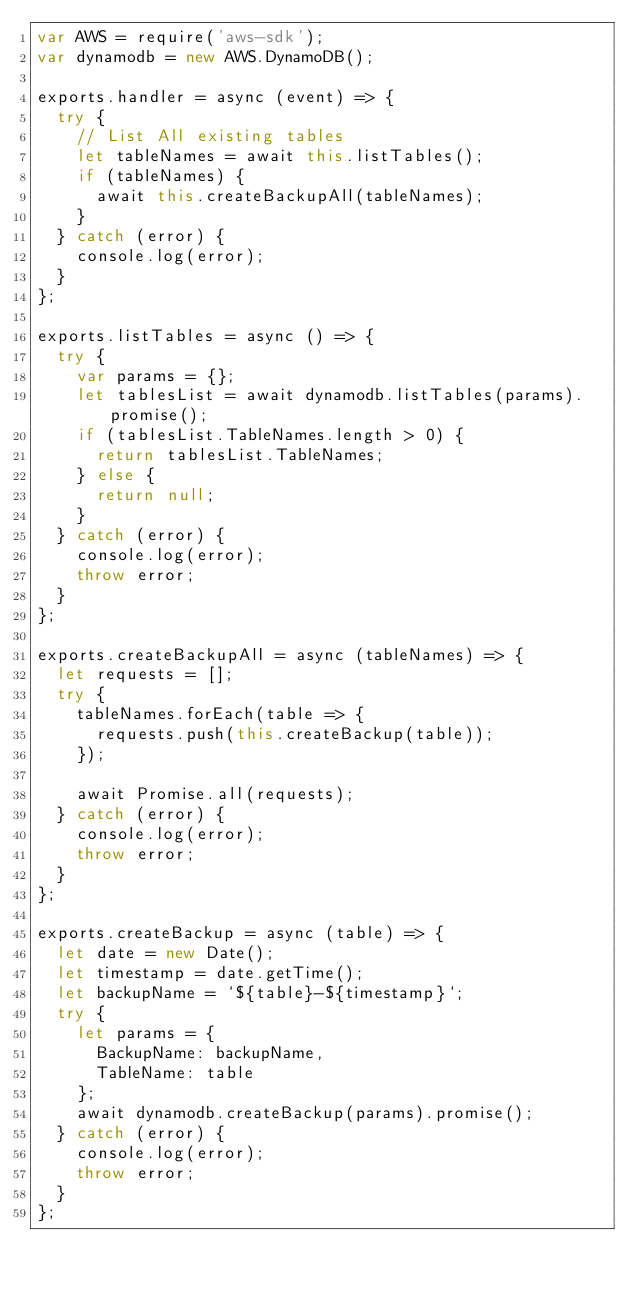<code> <loc_0><loc_0><loc_500><loc_500><_JavaScript_>var AWS = require('aws-sdk');
var dynamodb = new AWS.DynamoDB();

exports.handler = async (event) => {
  try {
    // List All existing tables
    let tableNames = await this.listTables();
    if (tableNames) {
      await this.createBackupAll(tableNames);
    }
  } catch (error) {
    console.log(error);
  }
};

exports.listTables = async () => {
  try {
    var params = {};
    let tablesList = await dynamodb.listTables(params).promise();
    if (tablesList.TableNames.length > 0) {
      return tablesList.TableNames;
    } else {
      return null;
    }
  } catch (error) {
    console.log(error);
    throw error;
  }
};

exports.createBackupAll = async (tableNames) => {
  let requests = [];
  try {
    tableNames.forEach(table => {
      requests.push(this.createBackup(table));
    });

    await Promise.all(requests);
  } catch (error) {
    console.log(error);
    throw error;
  }
};

exports.createBackup = async (table) => {
  let date = new Date();
  let timestamp = date.getTime();
  let backupName = `${table}-${timestamp}`;
  try {
    let params = {
      BackupName: backupName,
      TableName: table
    };
    await dynamodb.createBackup(params).promise();
  } catch (error) {
    console.log(error);
    throw error;
  }
};
</code> 